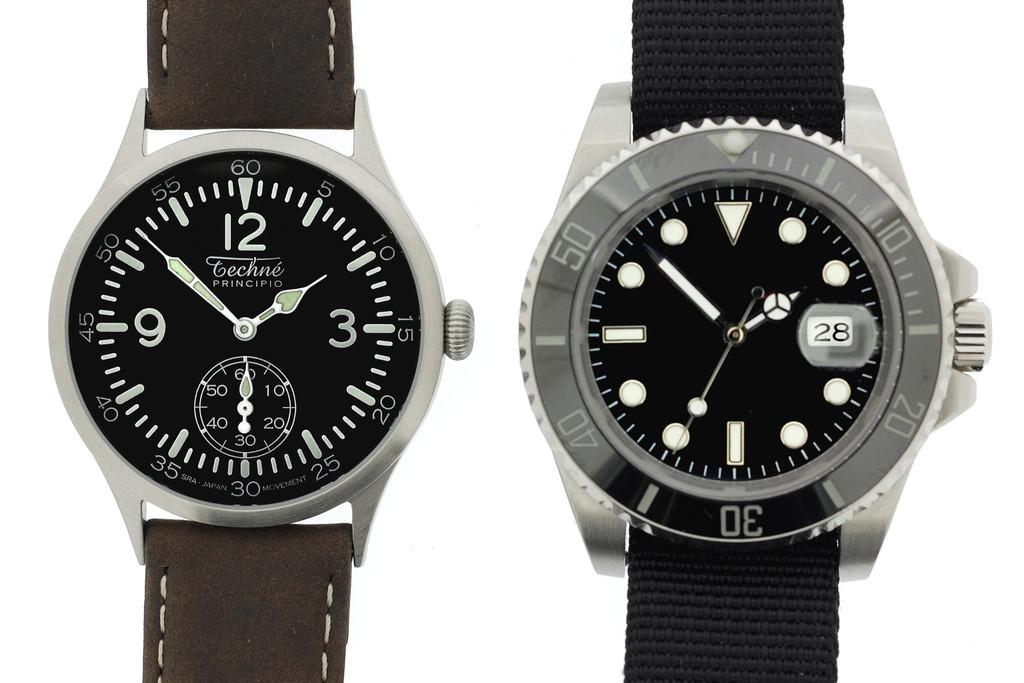<image>
Render a clear and concise summary of the photo. two Techne Principio wrist watches on display over a white background 